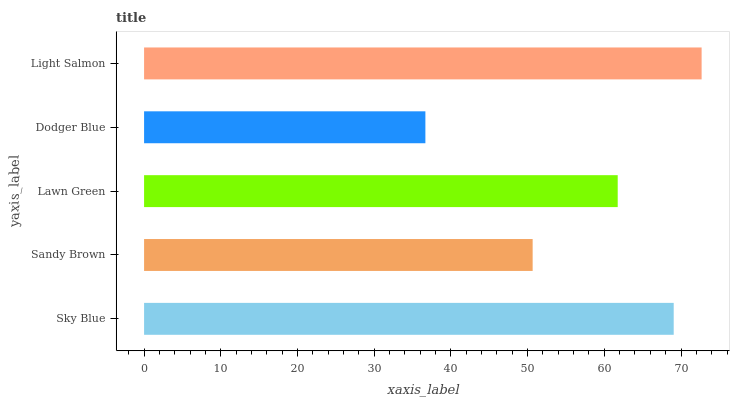Is Dodger Blue the minimum?
Answer yes or no. Yes. Is Light Salmon the maximum?
Answer yes or no. Yes. Is Sandy Brown the minimum?
Answer yes or no. No. Is Sandy Brown the maximum?
Answer yes or no. No. Is Sky Blue greater than Sandy Brown?
Answer yes or no. Yes. Is Sandy Brown less than Sky Blue?
Answer yes or no. Yes. Is Sandy Brown greater than Sky Blue?
Answer yes or no. No. Is Sky Blue less than Sandy Brown?
Answer yes or no. No. Is Lawn Green the high median?
Answer yes or no. Yes. Is Lawn Green the low median?
Answer yes or no. Yes. Is Sandy Brown the high median?
Answer yes or no. No. Is Sky Blue the low median?
Answer yes or no. No. 